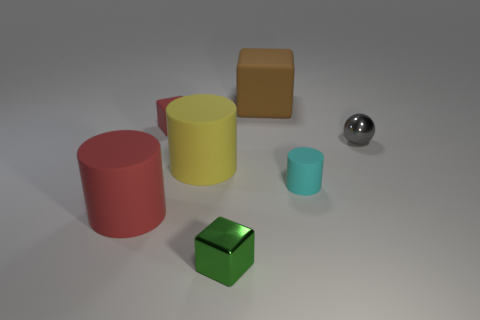What could be the possible materials of these objects? Based on the visual qualities, the red and yellow objects might be made of a matte plastic. The brown cube looks like it could be wooden, while the silver sphere seems metallic due to its reflective surface. How might the different textures of these materials affect the lighting in this image? Matte surfaces, like those of the colored cylinders and cube, diffuse light, softening shadows and reflections. In contrast, the metallic sphere reflects light strongly, creating sharper, clearer reflections and highlights. 